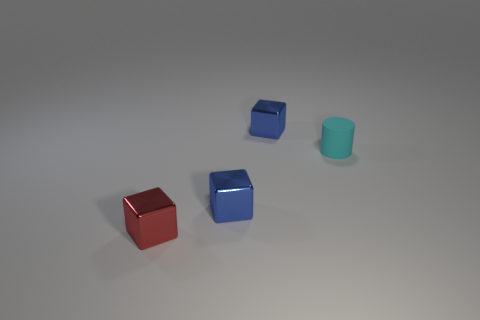Add 3 tiny shiny spheres. How many objects exist? 7 Subtract all cylinders. How many objects are left? 3 Add 1 small red things. How many small red things exist? 2 Subtract 0 purple cylinders. How many objects are left? 4 Subtract all cyan things. Subtract all cyan rubber things. How many objects are left? 2 Add 4 small metallic things. How many small metallic things are left? 7 